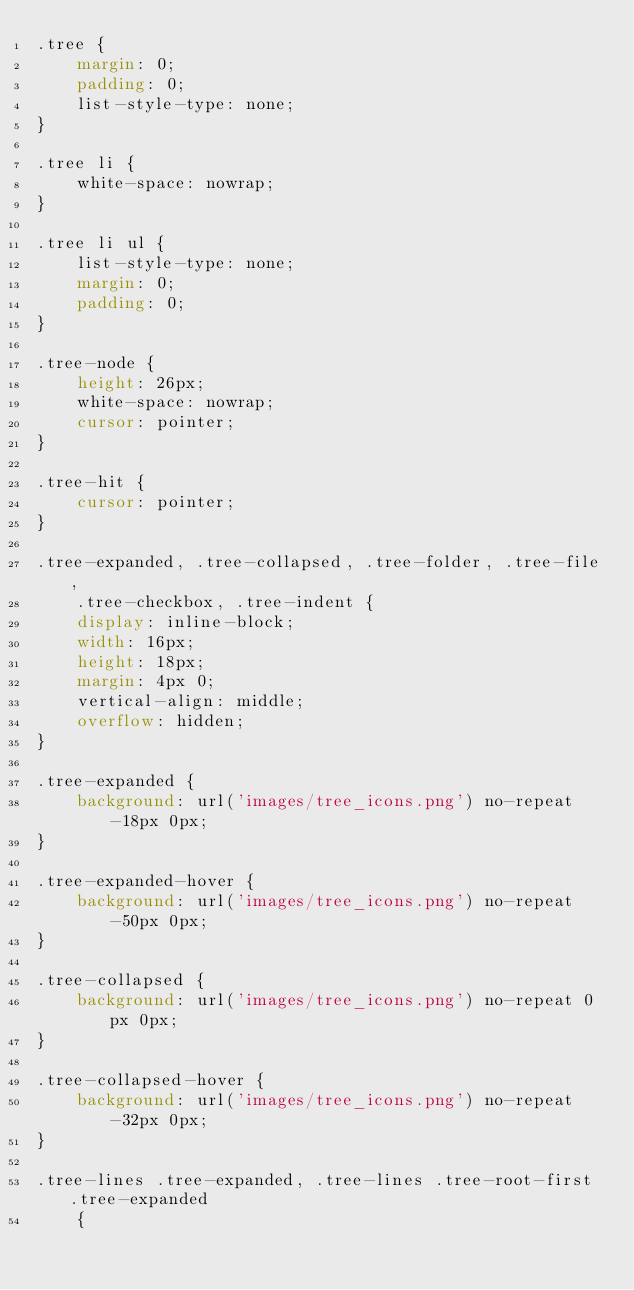<code> <loc_0><loc_0><loc_500><loc_500><_CSS_>.tree {
	margin: 0;
	padding: 0;
	list-style-type: none;
}

.tree li {
	white-space: nowrap;
}

.tree li ul {
	list-style-type: none;
	margin: 0;
	padding: 0;
}

.tree-node {
	height: 26px;
	white-space: nowrap;
	cursor: pointer;
}

.tree-hit {
	cursor: pointer;
}

.tree-expanded, .tree-collapsed, .tree-folder, .tree-file,
	.tree-checkbox, .tree-indent {
	display: inline-block;
	width: 16px;
	height: 18px;
	margin: 4px 0;
	vertical-align: middle;
	overflow: hidden;
}

.tree-expanded {
	background: url('images/tree_icons.png') no-repeat -18px 0px;
}

.tree-expanded-hover {
	background: url('images/tree_icons.png') no-repeat -50px 0px;
}

.tree-collapsed {
	background: url('images/tree_icons.png') no-repeat 0px 0px;
}

.tree-collapsed-hover {
	background: url('images/tree_icons.png') no-repeat -32px 0px;
}

.tree-lines .tree-expanded, .tree-lines .tree-root-first .tree-expanded
	{</code> 